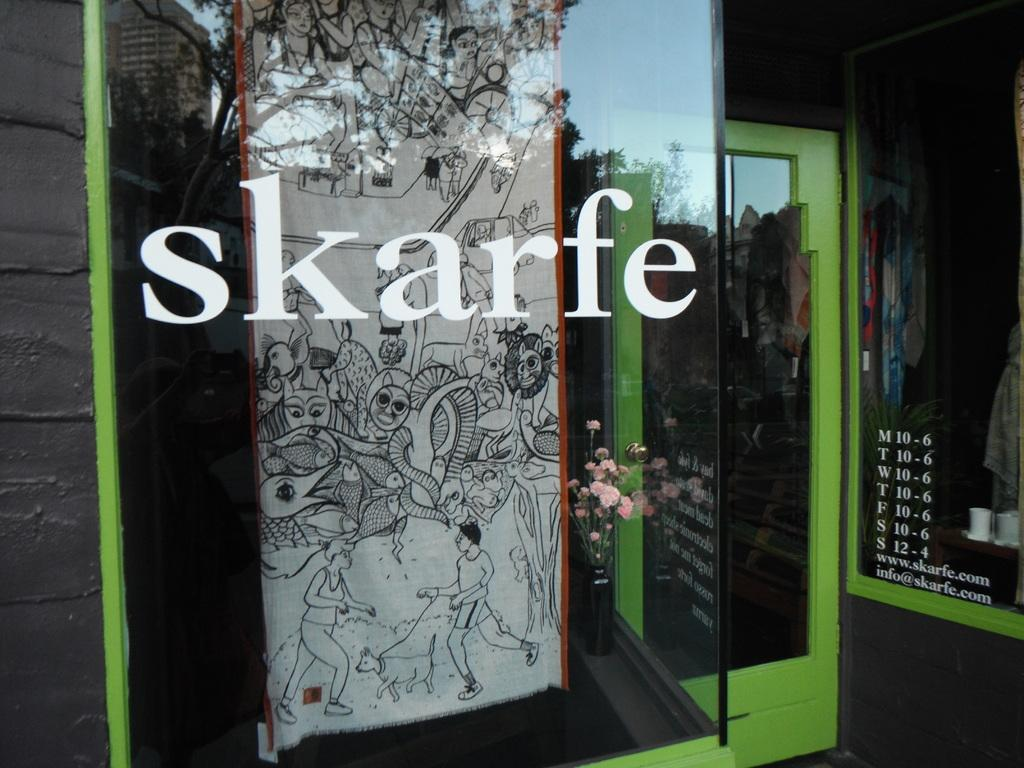What type of door is shown in the image? There is a glass door in the image. What is displayed on the glass door? Art and flowers are visible on the glass door. Are there any words or letters on the glass door? Yes, text is visible on the glass door. Can you see any rodents interacting with the glass door in the image? There are no rodents present in the image. How does the breath of the artist affect the art on the glass door? The image does not provide any information about the artist's breath or its effect on the art. 